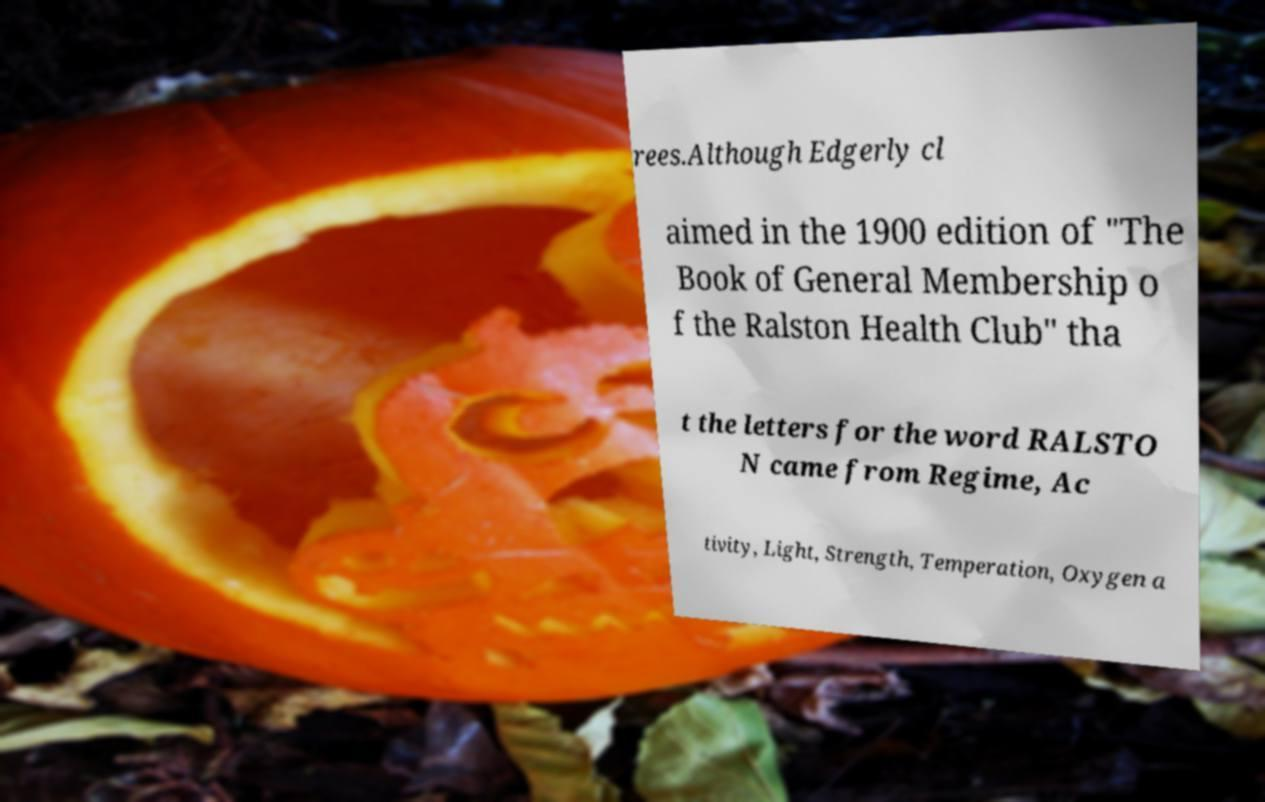For documentation purposes, I need the text within this image transcribed. Could you provide that? rees.Although Edgerly cl aimed in the 1900 edition of "The Book of General Membership o f the Ralston Health Club" tha t the letters for the word RALSTO N came from Regime, Ac tivity, Light, Strength, Temperation, Oxygen a 